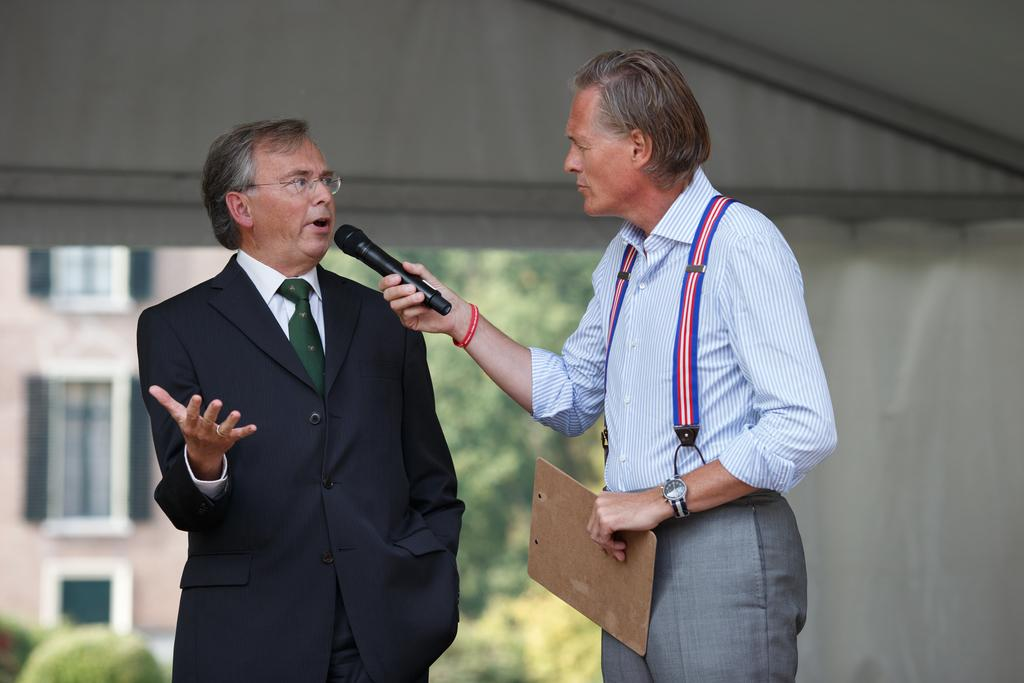How many people are in the image? There are two persons standing in the image. What is one person holding? One person is holding a mic. What can be seen in the background of the image? There is a building at the back side of the image. What is the mass of the work being done by the person holding the mic in the image? There is no work being done in the image, and therefore no mass can be associated with it. 